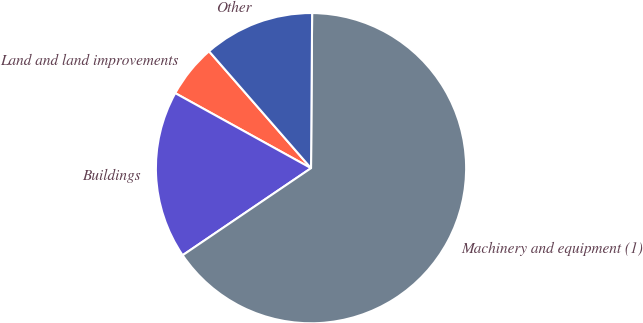<chart> <loc_0><loc_0><loc_500><loc_500><pie_chart><fcel>Land and land improvements<fcel>Buildings<fcel>Machinery and equipment (1)<fcel>Other<nl><fcel>5.55%<fcel>17.52%<fcel>65.4%<fcel>11.53%<nl></chart> 